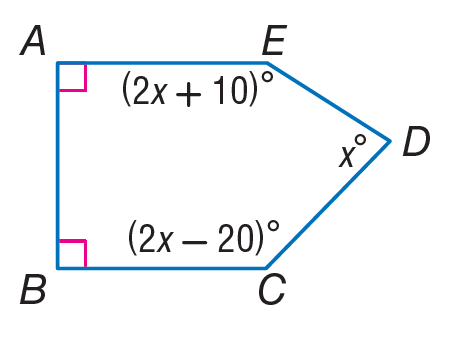Answer the mathemtical geometry problem and directly provide the correct option letter.
Question: Find m \angle A.
Choices: A: 45 B: 90 C: 180 D: 360 B 